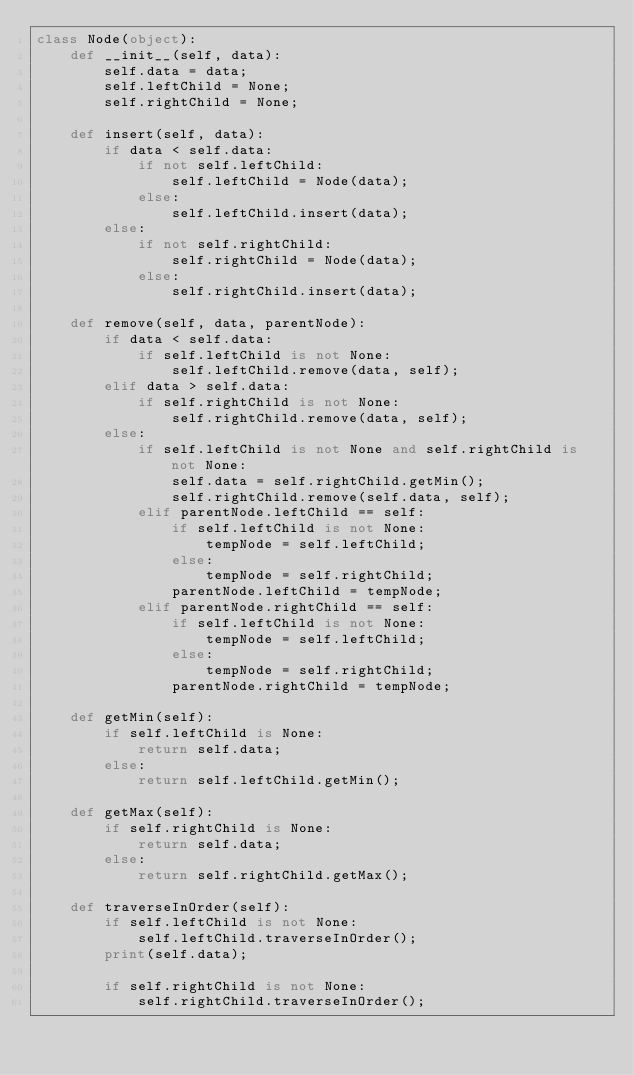Convert code to text. <code><loc_0><loc_0><loc_500><loc_500><_Python_>class Node(object):
    def __init__(self, data):
        self.data = data;
        self.leftChild = None;
        self.rightChild = None;

    def insert(self, data):
        if data < self.data:
            if not self.leftChild:
                self.leftChild = Node(data);
            else:
                self.leftChild.insert(data);
        else:
            if not self.rightChild:
                self.rightChild = Node(data);
            else:
                self.rightChild.insert(data);
    
    def remove(self, data, parentNode):
        if data < self.data:
            if self.leftChild is not None:
                self.leftChild.remove(data, self);
        elif data > self.data:
            if self.rightChild is not None:
                self.rightChild.remove(data, self);
        else:
            if self.leftChild is not None and self.rightChild is not None:
                self.data = self.rightChild.getMin();
                self.rightChild.remove(self.data, self);
            elif parentNode.leftChild == self:
                if self.leftChild is not None:
                    tempNode = self.leftChild;
                else:
                    tempNode = self.rightChild;
                parentNode.leftChild = tempNode;
            elif parentNode.rightChild == self:
                if self.leftChild is not None:
                    tempNode = self.leftChild;
                else:
                    tempNode = self.rightChild;
                parentNode.rightChild = tempNode;

    def getMin(self):
        if self.leftChild is None:
            return self.data;
        else:
            return self.leftChild.getMin();
    
    def getMax(self):
        if self.rightChild is None:
            return self.data;
        else:
            return self.rightChild.getMax();

    def traverseInOrder(self):
        if self.leftChild is not None:
            self.leftChild.traverseInOrder();
        print(self.data);

        if self.rightChild is not None:
            self.rightChild.traverseInOrder();
        
</code> 